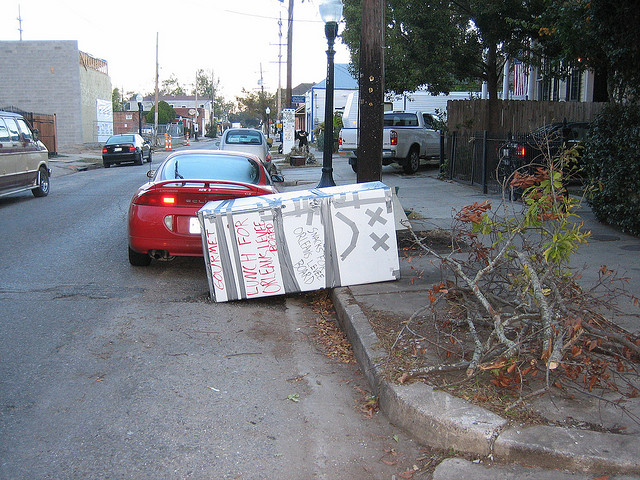<image>What color car is behind the box? I am not sure about the color of the car behind the box. It could be red or there might be no car. What color car is behind the box? There is a red car behind the box. 